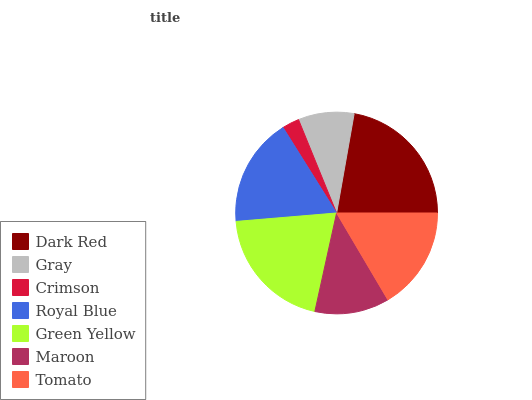Is Crimson the minimum?
Answer yes or no. Yes. Is Dark Red the maximum?
Answer yes or no. Yes. Is Gray the minimum?
Answer yes or no. No. Is Gray the maximum?
Answer yes or no. No. Is Dark Red greater than Gray?
Answer yes or no. Yes. Is Gray less than Dark Red?
Answer yes or no. Yes. Is Gray greater than Dark Red?
Answer yes or no. No. Is Dark Red less than Gray?
Answer yes or no. No. Is Tomato the high median?
Answer yes or no. Yes. Is Tomato the low median?
Answer yes or no. Yes. Is Royal Blue the high median?
Answer yes or no. No. Is Royal Blue the low median?
Answer yes or no. No. 